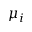<formula> <loc_0><loc_0><loc_500><loc_500>\mu _ { i }</formula> 